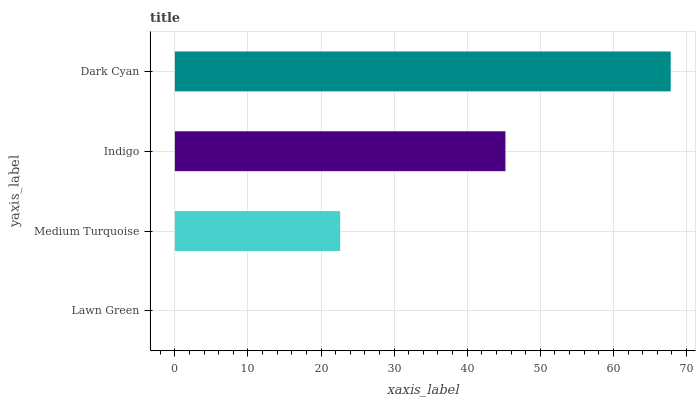Is Lawn Green the minimum?
Answer yes or no. Yes. Is Dark Cyan the maximum?
Answer yes or no. Yes. Is Medium Turquoise the minimum?
Answer yes or no. No. Is Medium Turquoise the maximum?
Answer yes or no. No. Is Medium Turquoise greater than Lawn Green?
Answer yes or no. Yes. Is Lawn Green less than Medium Turquoise?
Answer yes or no. Yes. Is Lawn Green greater than Medium Turquoise?
Answer yes or no. No. Is Medium Turquoise less than Lawn Green?
Answer yes or no. No. Is Indigo the high median?
Answer yes or no. Yes. Is Medium Turquoise the low median?
Answer yes or no. Yes. Is Dark Cyan the high median?
Answer yes or no. No. Is Dark Cyan the low median?
Answer yes or no. No. 